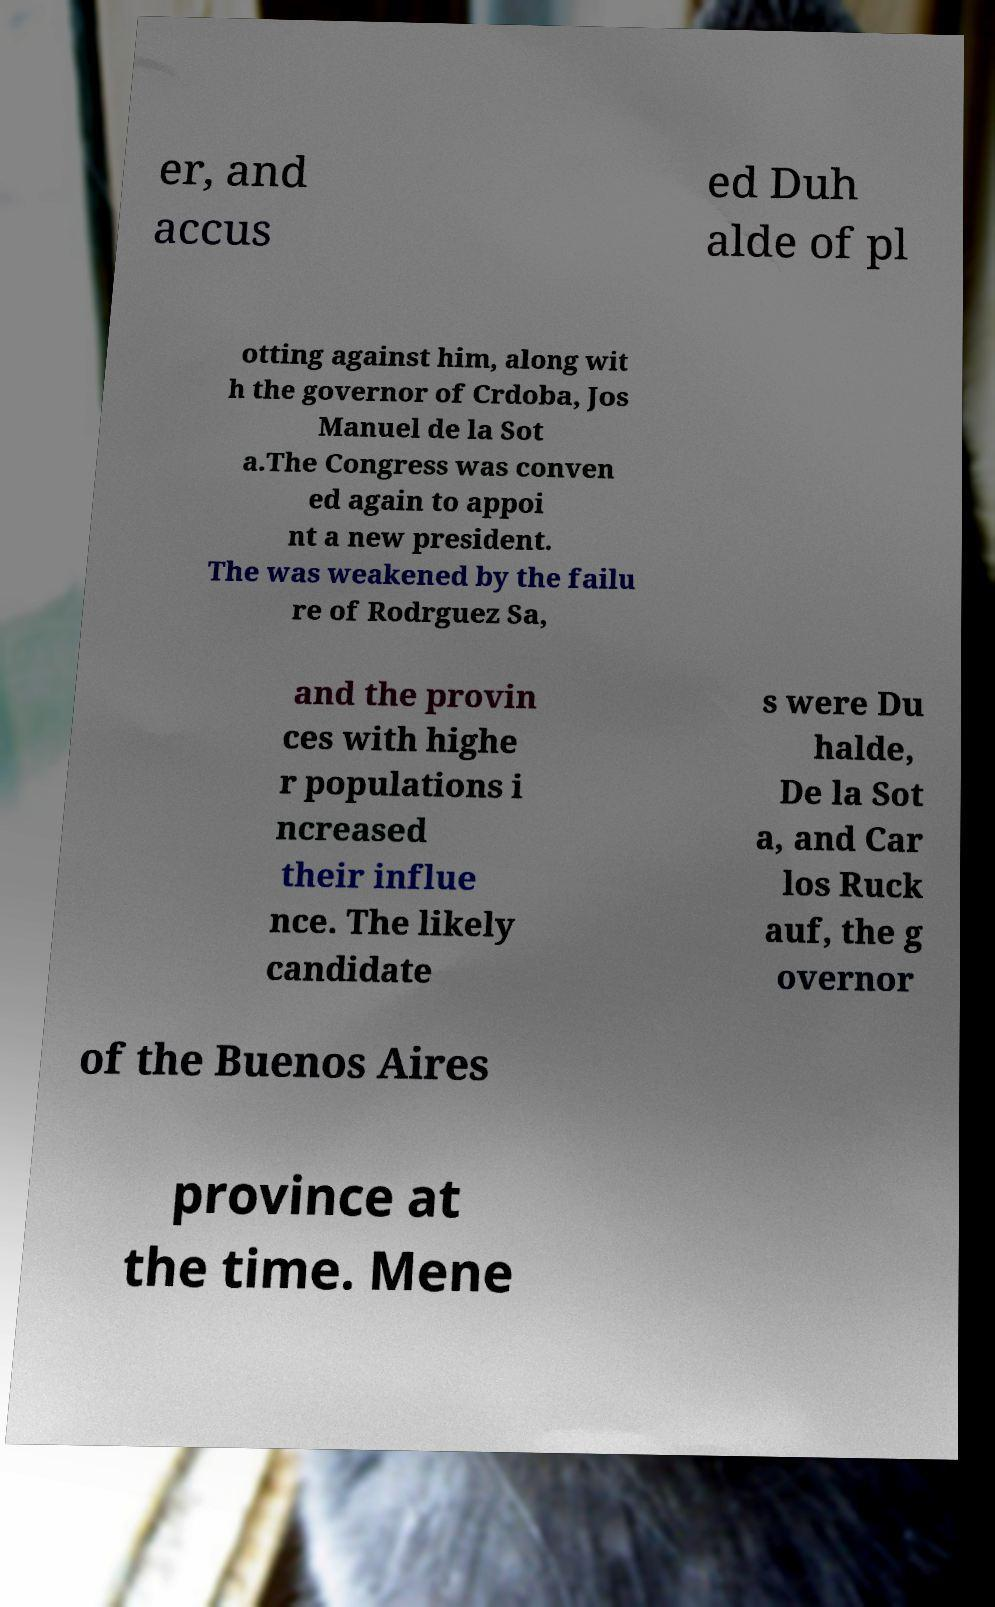Can you read and provide the text displayed in the image?This photo seems to have some interesting text. Can you extract and type it out for me? er, and accus ed Duh alde of pl otting against him, along wit h the governor of Crdoba, Jos Manuel de la Sot a.The Congress was conven ed again to appoi nt a new president. The was weakened by the failu re of Rodrguez Sa, and the provin ces with highe r populations i ncreased their influe nce. The likely candidate s were Du halde, De la Sot a, and Car los Ruck auf, the g overnor of the Buenos Aires province at the time. Mene 